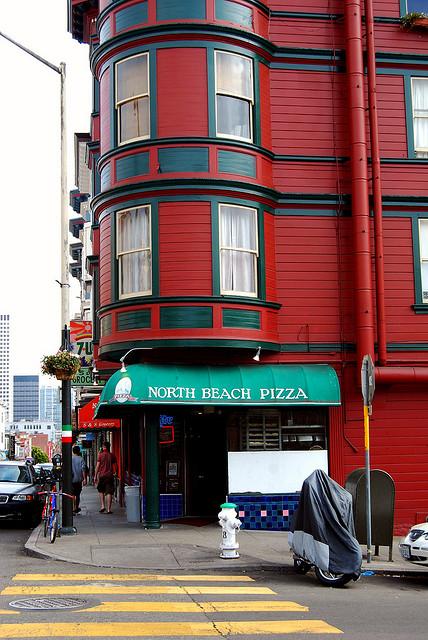What is underneath the gray cover?
Answer briefly. Motorcycle. What color is the building?
Quick response, please. Red. What does the sign say?
Be succinct. North beach pizza. 